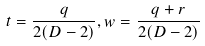Convert formula to latex. <formula><loc_0><loc_0><loc_500><loc_500>t = \frac { q } { 2 ( D - 2 ) } , w = \frac { q + r } { 2 ( D - 2 ) }</formula> 